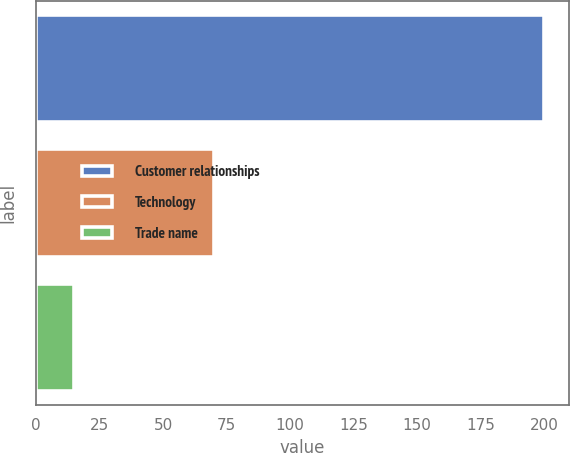Convert chart. <chart><loc_0><loc_0><loc_500><loc_500><bar_chart><fcel>Customer relationships<fcel>Technology<fcel>Trade name<nl><fcel>200<fcel>70<fcel>15<nl></chart> 